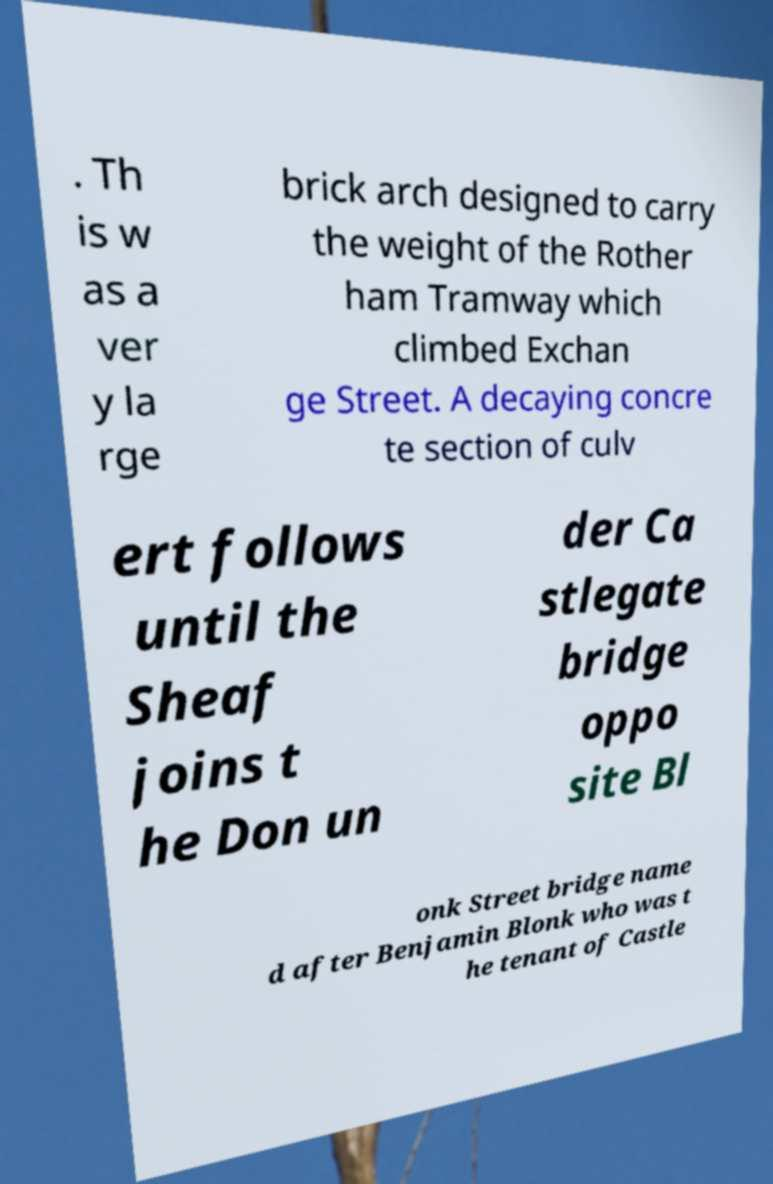Can you accurately transcribe the text from the provided image for me? . Th is w as a ver y la rge brick arch designed to carry the weight of the Rother ham Tramway which climbed Exchan ge Street. A decaying concre te section of culv ert follows until the Sheaf joins t he Don un der Ca stlegate bridge oppo site Bl onk Street bridge name d after Benjamin Blonk who was t he tenant of Castle 